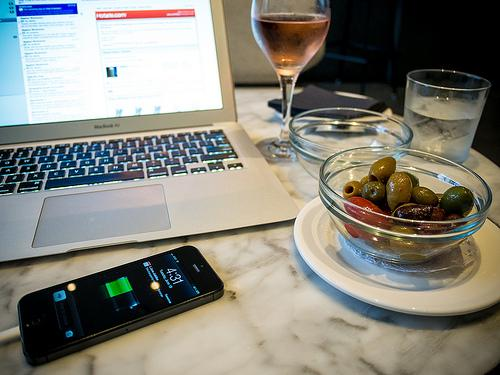Explain the scene on the white granite table top. A variety of objects like a wine glass, iPhone, laptop, napkins, and bowls with green olives, and glasses with water and wine are organized on a white granite table top. What can be observed about the water in the clear glass? The clear glass contains ice water. What kind of fruit can be seen in one of the clear bowls? A clear bowl contains green olives. Describe the state of the laptop computer in the image. The laptop computer is open with its keyboard, touchpad, and screen visible. Identify the type of charger used for the iPhone in the image. The iPhone is connected to a battery charger with a green bar. What objects are present on the white granite table top? There are wine glass, empty bowl, iPhone, laptop computer, stack of black napkins, clear glass of water, white plate, and bowl of green olives on the table. Tell me about the beverages depicted in the image and their respective containers. There is a glass of wine filled halfway with wine and a clear glass filled with ice water. Describe the primary electronic devices seen in the image. A black apple iPhone being charged and an open white laptop computer with visible keyboard, touchpad, and screen are the primary electronic devices in the image. Identify the various items found in the image and their respective emotions/actions based on the objects' characteristics.  N/A What is the laptop's relationship with its components such as the touchpad, keyboard, and monitor screen? touchpad and keyboard are part of the laptop base, monitor screen is the laptop's display What time is shown on the device? 431 Identify any potential components of the laptop visible in the image. Keyboard, touchpad, monitor screen Describe in detail the arrangement on the white plate. a clear glass bowl filled with green olives placed on the white plate Create a detailed and vibrant image by combining the elements found within the existing image, such as the wine glass, the charging iPhone, and the stack of black napkins. A cozy and elegant atmosphere surrounds a neatly set table with a wine glass filled with rich red wine, an iPhone charging next to it, and a stack of finely folded black napkins adding a touch of class. Describe the appearance and position of the charging iPhone. Black iPhone, on the left side of the image, battery charge screen visible Describe the laptop computer in the image. White, open, silver touchpad, and keys on the keyboard visible What do you see in the glass next to the wine glass? Ice water Analyze the image and identify any possible functions or connections between the various items displayed. Phone is charging with a cable, laptop is used for work or communication, wine and water glasses used for drinking, olives on plate for eating Notice how the red rose placed inside the empty clear glass bowl adds a touch of elegance to the table setting. No, it's not mentioned in the image. Find the tiny red and white striped umbrella sitting atop the rim of the glass of wine. There is no tiny red and white striped umbrella listed in the image information. This instruction is misleading because it adds a completely unrelated and nonexistent object to an existing one, making the reader look for a specific detail that is not present in the image. List the devices/screens present in the image. black apple iphone, open white laptop computer Just above the open white laptop, there is a small kitten playing with the keyboard. Can you see it? No small kitten is mentioned in the image information. This instruction is misleading as it not only refers to a non-existent object but also implies an action (playing with the keyboard) that cannot be seen in any static image. Look for the tall blooming cactus that stands right beside the glass of water. The image information does not include a tall blooming cactus. This instruction is misleading because it uses descriptive details to create a false image of a non-existent object next to a real one, making the reader look for an unmentioned item. What are the different types of items on the table? Can you provide an accurate description of each item? wine glass with wine, black iphone charging, clear glass with ice water, white granite table top, stack of black napkins, small white plate, clear glass bowl with olives, open white laptop computer, black arms of chair How many green olives can you see in the clear glass bowl? Unable to determine the exact number What appears to be happening with the cell phone and laptop? cell phone is charging, laptop is open and in use Can you locate the slice of pizza on the white plate in the middle of the table? There is no mention of a slice of pizza in any of the objects listed in the image. This instruction is misleading because it refers to a non-existent object and asks the reader to find its location. How is the battery performing according to its displayed charge status, and is the phone charging? battery has a green bar, iphone is charging What kind of event or activity might be occurring considering all the objects present in the image? a gathering or meeting with food and drinks, possibly a work-related event What type of table is depicted in the image and what is its appearance? White granite table top Which of the following options accurately describes the state of the glass of water: a) empty, b) filled to the brim, c) filled halfway? c) filled halfway 